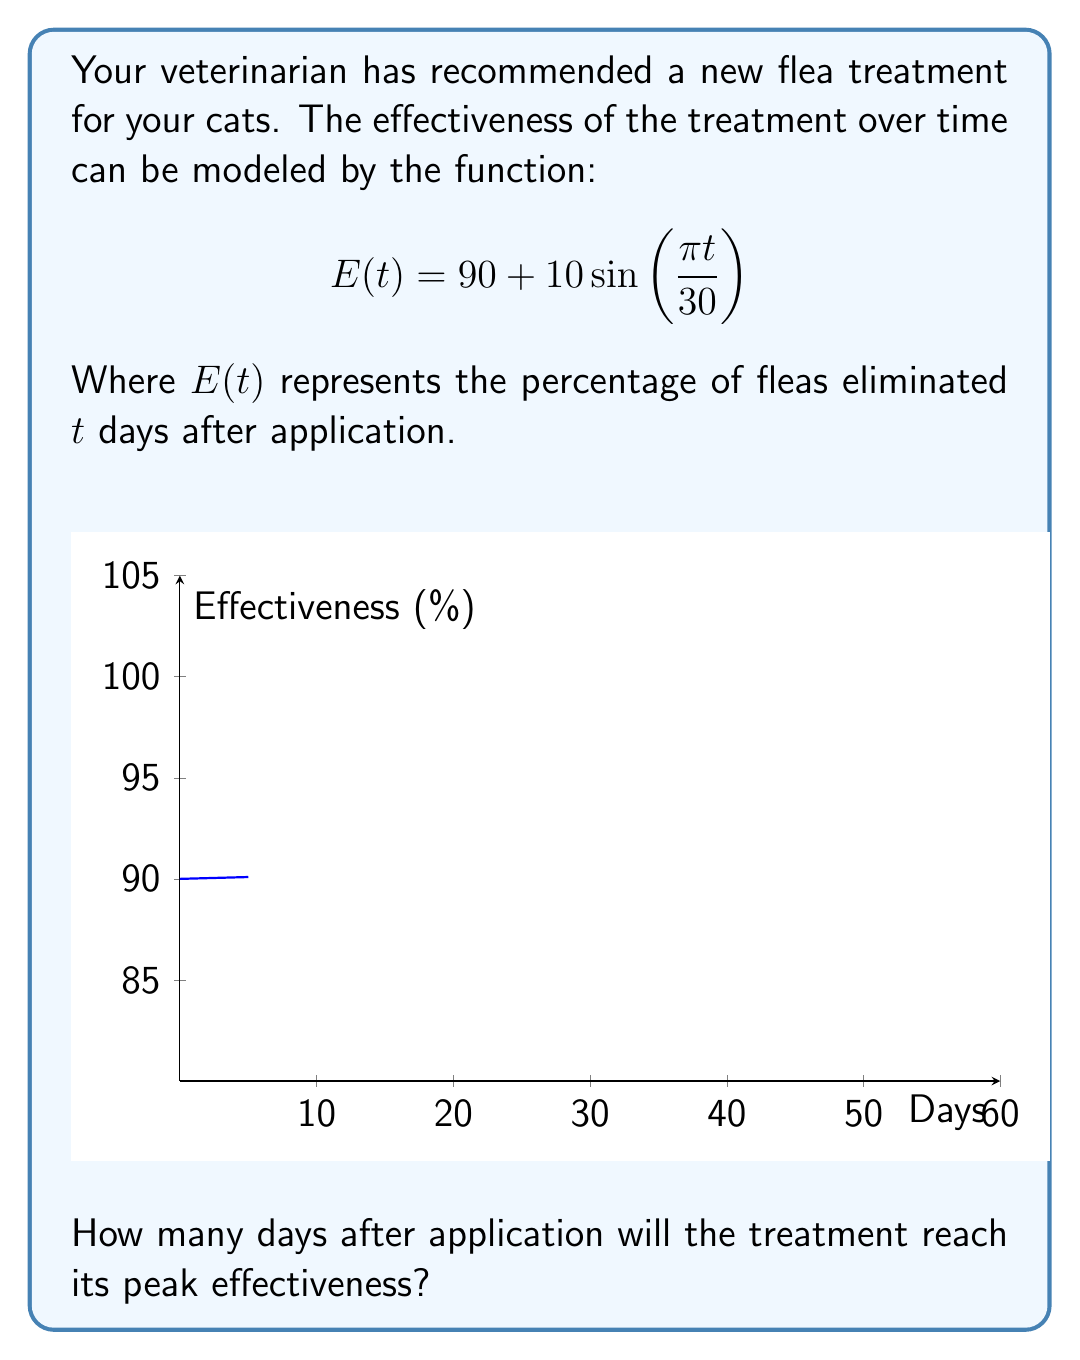Could you help me with this problem? Let's approach this step-by-step:

1) The sine function reaches its maximum value when its argument is $\frac{\pi}{2}$ (or 90°).

2) In our function, the argument of sine is $\frac{\pi t}{30}$. We need to find when this equals $\frac{\pi}{2}$:

   $$\frac{\pi t}{30} = \frac{\pi}{2}$$

3) To solve for $t$, multiply both sides by $\frac{30}{\pi}$:

   $$t = \frac{30}{\pi} \cdot \frac{\pi}{2} = 15$$

4) Therefore, the treatment reaches its peak effectiveness after 15 days.

5) We can verify this by calculating $E(15)$:

   $$E(15) = 90 + 10\sin(\frac{\pi \cdot 15}{30}) = 90 + 10\sin(\frac{\pi}{2}) = 90 + 10 = 100$$

   This confirms that at $t=15$, the effectiveness is at its maximum of 100%.
Answer: 15 days 